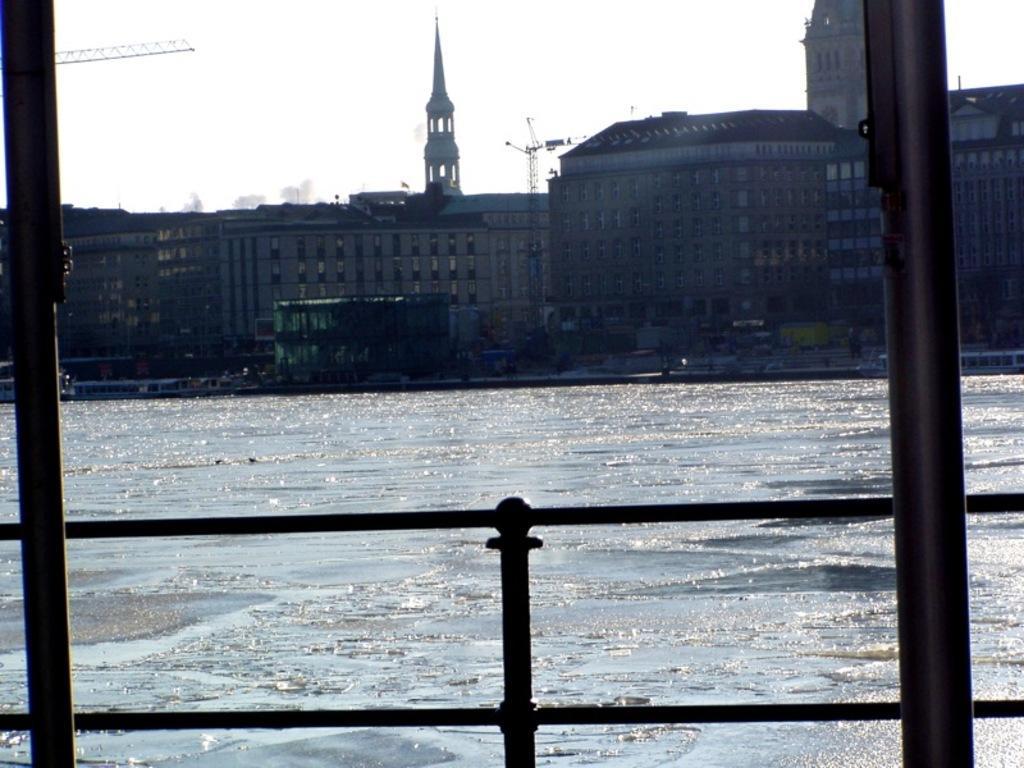Can you describe this image briefly? In this image we can see railing and poles. Behind the railing, lake and buildings are present. At the top of the image, there is the sky. 